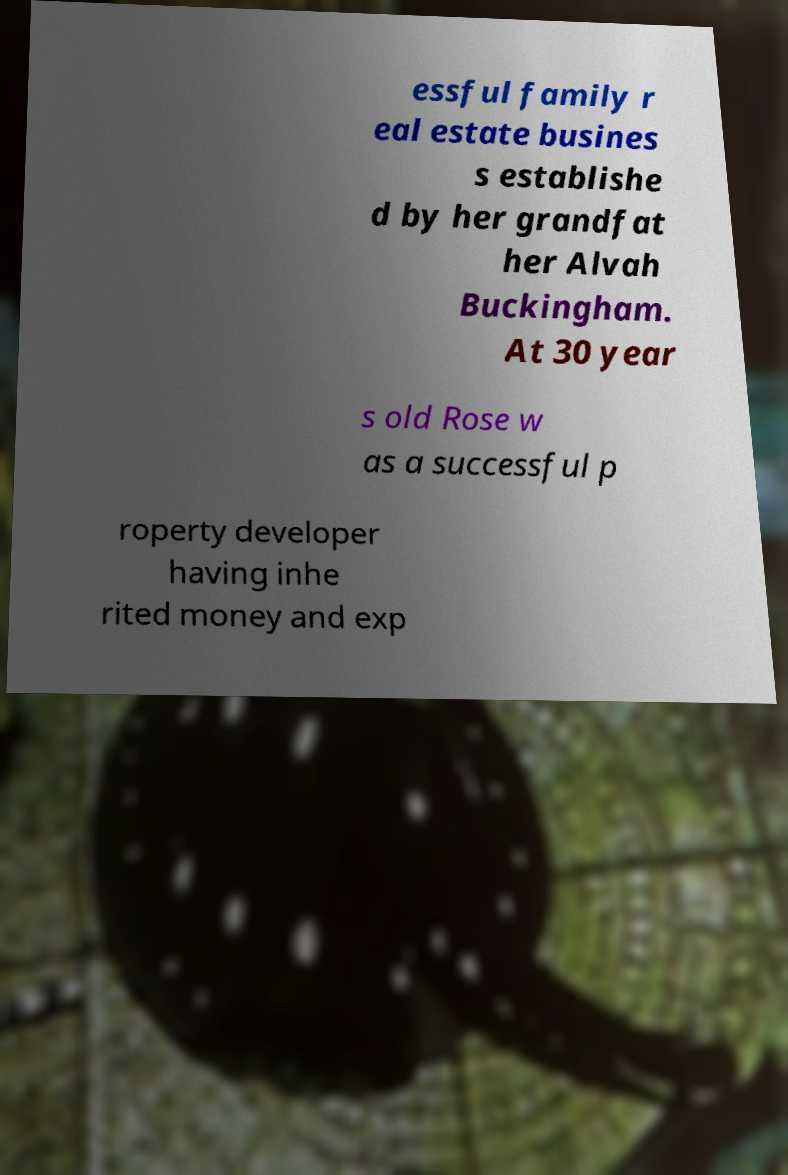Can you read and provide the text displayed in the image?This photo seems to have some interesting text. Can you extract and type it out for me? essful family r eal estate busines s establishe d by her grandfat her Alvah Buckingham. At 30 year s old Rose w as a successful p roperty developer having inhe rited money and exp 